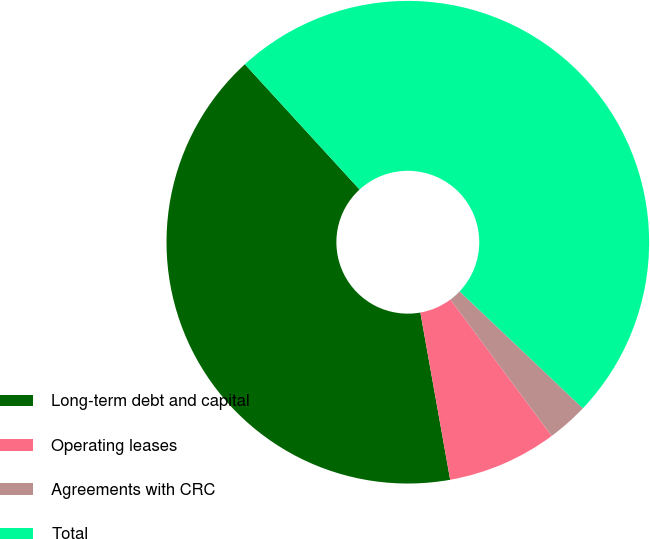Convert chart to OTSL. <chart><loc_0><loc_0><loc_500><loc_500><pie_chart><fcel>Long-term debt and capital<fcel>Operating leases<fcel>Agreements with CRC<fcel>Total<nl><fcel>41.01%<fcel>7.36%<fcel>2.75%<fcel>48.88%<nl></chart> 